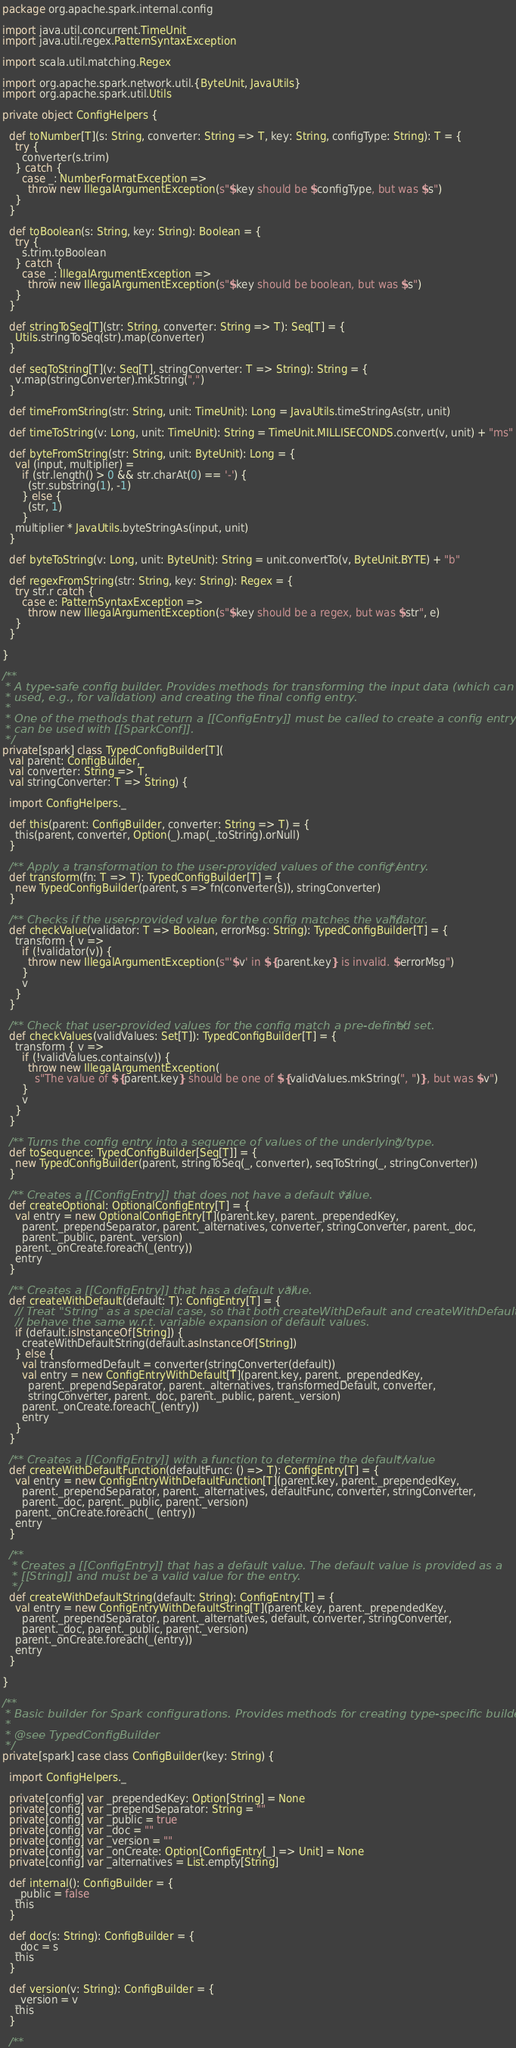<code> <loc_0><loc_0><loc_500><loc_500><_Scala_>
package org.apache.spark.internal.config

import java.util.concurrent.TimeUnit
import java.util.regex.PatternSyntaxException

import scala.util.matching.Regex

import org.apache.spark.network.util.{ByteUnit, JavaUtils}
import org.apache.spark.util.Utils

private object ConfigHelpers {

  def toNumber[T](s: String, converter: String => T, key: String, configType: String): T = {
    try {
      converter(s.trim)
    } catch {
      case _: NumberFormatException =>
        throw new IllegalArgumentException(s"$key should be $configType, but was $s")
    }
  }

  def toBoolean(s: String, key: String): Boolean = {
    try {
      s.trim.toBoolean
    } catch {
      case _: IllegalArgumentException =>
        throw new IllegalArgumentException(s"$key should be boolean, but was $s")
    }
  }

  def stringToSeq[T](str: String, converter: String => T): Seq[T] = {
    Utils.stringToSeq(str).map(converter)
  }

  def seqToString[T](v: Seq[T], stringConverter: T => String): String = {
    v.map(stringConverter).mkString(",")
  }

  def timeFromString(str: String, unit: TimeUnit): Long = JavaUtils.timeStringAs(str, unit)

  def timeToString(v: Long, unit: TimeUnit): String = TimeUnit.MILLISECONDS.convert(v, unit) + "ms"

  def byteFromString(str: String, unit: ByteUnit): Long = {
    val (input, multiplier) =
      if (str.length() > 0 && str.charAt(0) == '-') {
        (str.substring(1), -1)
      } else {
        (str, 1)
      }
    multiplier * JavaUtils.byteStringAs(input, unit)
  }

  def byteToString(v: Long, unit: ByteUnit): String = unit.convertTo(v, ByteUnit.BYTE) + "b"

  def regexFromString(str: String, key: String): Regex = {
    try str.r catch {
      case e: PatternSyntaxException =>
        throw new IllegalArgumentException(s"$key should be a regex, but was $str", e)
    }
  }

}

/**
 * A type-safe config builder. Provides methods for transforming the input data (which can be
 * used, e.g., for validation) and creating the final config entry.
 *
 * One of the methods that return a [[ConfigEntry]] must be called to create a config entry that
 * can be used with [[SparkConf]].
 */
private[spark] class TypedConfigBuilder[T](
  val parent: ConfigBuilder,
  val converter: String => T,
  val stringConverter: T => String) {

  import ConfigHelpers._

  def this(parent: ConfigBuilder, converter: String => T) = {
    this(parent, converter, Option(_).map(_.toString).orNull)
  }

  /** Apply a transformation to the user-provided values of the config entry. */
  def transform(fn: T => T): TypedConfigBuilder[T] = {
    new TypedConfigBuilder(parent, s => fn(converter(s)), stringConverter)
  }

  /** Checks if the user-provided value for the config matches the validator. */
  def checkValue(validator: T => Boolean, errorMsg: String): TypedConfigBuilder[T] = {
    transform { v =>
      if (!validator(v)) {
        throw new IllegalArgumentException(s"'$v' in ${parent.key} is invalid. $errorMsg")
      }
      v
    }
  }

  /** Check that user-provided values for the config match a pre-defined set. */
  def checkValues(validValues: Set[T]): TypedConfigBuilder[T] = {
    transform { v =>
      if (!validValues.contains(v)) {
        throw new IllegalArgumentException(
          s"The value of ${parent.key} should be one of ${validValues.mkString(", ")}, but was $v")
      }
      v
    }
  }

  /** Turns the config entry into a sequence of values of the underlying type. */
  def toSequence: TypedConfigBuilder[Seq[T]] = {
    new TypedConfigBuilder(parent, stringToSeq(_, converter), seqToString(_, stringConverter))
  }

  /** Creates a [[ConfigEntry]] that does not have a default value. */
  def createOptional: OptionalConfigEntry[T] = {
    val entry = new OptionalConfigEntry[T](parent.key, parent._prependedKey,
      parent._prependSeparator, parent._alternatives, converter, stringConverter, parent._doc,
      parent._public, parent._version)
    parent._onCreate.foreach(_(entry))
    entry
  }

  /** Creates a [[ConfigEntry]] that has a default value. */
  def createWithDefault(default: T): ConfigEntry[T] = {
    // Treat "String" as a special case, so that both createWithDefault and createWithDefaultString
    // behave the same w.r.t. variable expansion of default values.
    if (default.isInstanceOf[String]) {
      createWithDefaultString(default.asInstanceOf[String])
    } else {
      val transformedDefault = converter(stringConverter(default))
      val entry = new ConfigEntryWithDefault[T](parent.key, parent._prependedKey,
        parent._prependSeparator, parent._alternatives, transformedDefault, converter,
        stringConverter, parent._doc, parent._public, parent._version)
      parent._onCreate.foreach(_(entry))
      entry
    }
  }

  /** Creates a [[ConfigEntry]] with a function to determine the default value */
  def createWithDefaultFunction(defaultFunc: () => T): ConfigEntry[T] = {
    val entry = new ConfigEntryWithDefaultFunction[T](parent.key, parent._prependedKey,
      parent._prependSeparator, parent._alternatives, defaultFunc, converter, stringConverter,
      parent._doc, parent._public, parent._version)
    parent._onCreate.foreach(_ (entry))
    entry
  }

  /**
   * Creates a [[ConfigEntry]] that has a default value. The default value is provided as a
   * [[String]] and must be a valid value for the entry.
   */
  def createWithDefaultString(default: String): ConfigEntry[T] = {
    val entry = new ConfigEntryWithDefaultString[T](parent.key, parent._prependedKey,
      parent._prependSeparator, parent._alternatives, default, converter, stringConverter,
      parent._doc, parent._public, parent._version)
    parent._onCreate.foreach(_(entry))
    entry
  }

}

/**
 * Basic builder for Spark configurations. Provides methods for creating type-specific builders.
 *
 * @see TypedConfigBuilder
 */
private[spark] case class ConfigBuilder(key: String) {

  import ConfigHelpers._

  private[config] var _prependedKey: Option[String] = None
  private[config] var _prependSeparator: String = ""
  private[config] var _public = true
  private[config] var _doc = ""
  private[config] var _version = ""
  private[config] var _onCreate: Option[ConfigEntry[_] => Unit] = None
  private[config] var _alternatives = List.empty[String]

  def internal(): ConfigBuilder = {
    _public = false
    this
  }

  def doc(s: String): ConfigBuilder = {
    _doc = s
    this
  }

  def version(v: String): ConfigBuilder = {
    _version = v
    this
  }

  /**</code> 